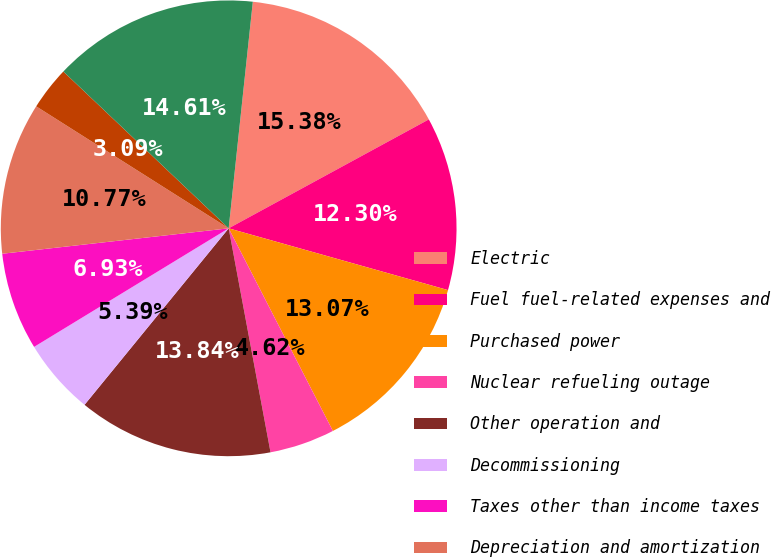Convert chart to OTSL. <chart><loc_0><loc_0><loc_500><loc_500><pie_chart><fcel>Electric<fcel>Fuel fuel-related expenses and<fcel>Purchased power<fcel>Nuclear refueling outage<fcel>Other operation and<fcel>Decommissioning<fcel>Taxes other than income taxes<fcel>Depreciation and amortization<fcel>Other regulatory charges<fcel>TOTAL<nl><fcel>15.38%<fcel>12.3%<fcel>13.07%<fcel>4.62%<fcel>13.84%<fcel>5.39%<fcel>6.93%<fcel>10.77%<fcel>3.09%<fcel>14.61%<nl></chart> 